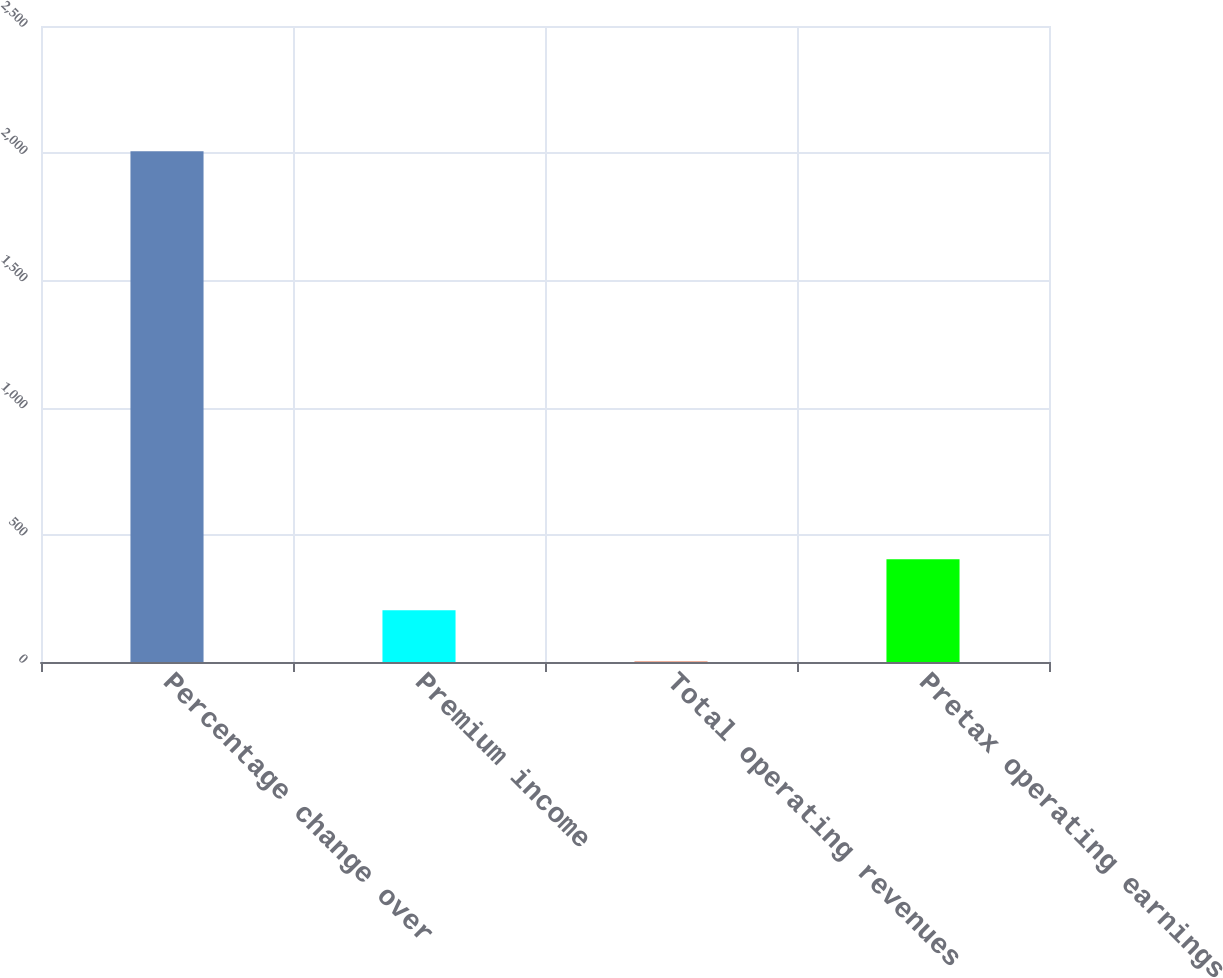<chart> <loc_0><loc_0><loc_500><loc_500><bar_chart><fcel>Percentage change over<fcel>Premium income<fcel>Total operating revenues<fcel>Pretax operating earnings<nl><fcel>2008<fcel>203.32<fcel>2.8<fcel>403.84<nl></chart> 